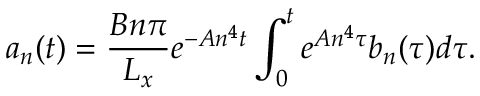<formula> <loc_0><loc_0><loc_500><loc_500>a _ { n } ( t ) = \frac { B n \pi } { L _ { x } } e ^ { - A n ^ { 4 } t } \int _ { 0 } ^ { t } e ^ { A n ^ { 4 } \tau } b _ { n } ( \tau ) d \tau .</formula> 